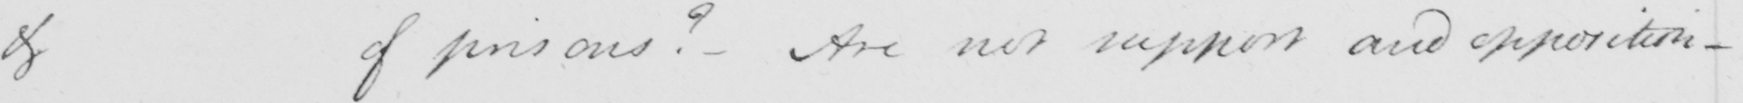Can you read and transcribe this handwriting? of of pensions ?  - Are not support and opposition - 